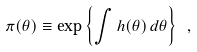Convert formula to latex. <formula><loc_0><loc_0><loc_500><loc_500>\pi ( \theta ) \equiv \exp { \left \{ \int h ( \theta ) \, d \theta \right \} } \ ,</formula> 